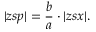<formula> <loc_0><loc_0><loc_500><loc_500>| z s p | = { \frac { b } { a } } \cdot | z s x | .</formula> 